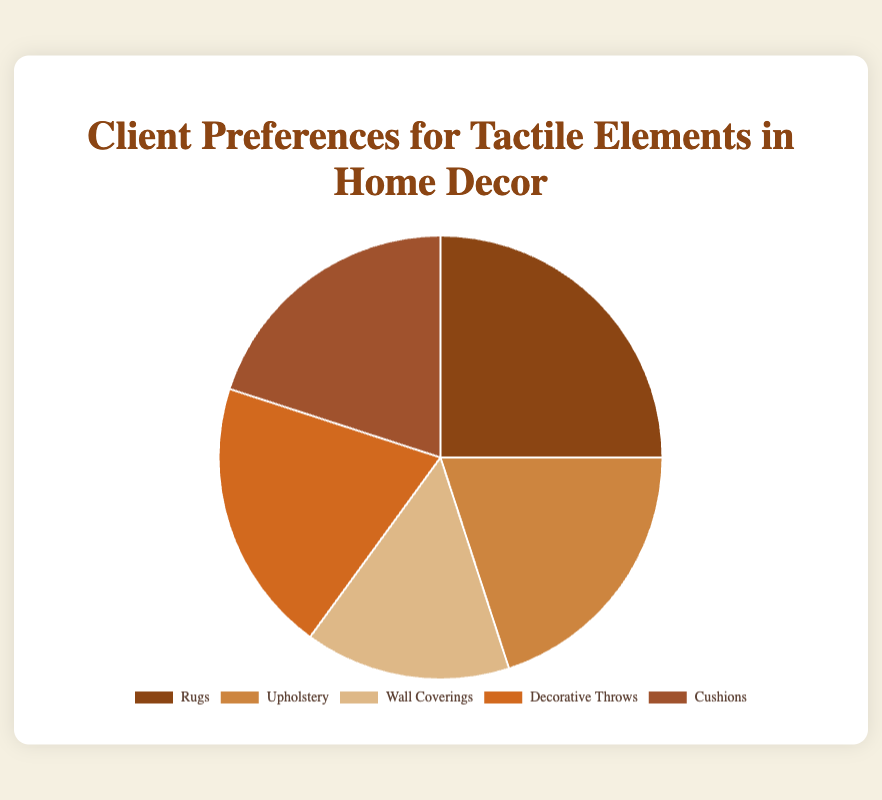What percentage of clients prefer Rugs? The segment labeled "Rugs" in the pie chart represents 25% of the preferences.
Answer: 25% Which categories have equal client preference percentages? The pie chart shows that Upholstery, Decorative Throws, and Cushions each have a preference percentage of 20%.
Answer: Upholstery, Decorative Throws, Cushions What is the combined percentage preference for Upholstery and Cushions? Add the percentages for Upholstery (20%) and Cushions (20%): 20% + 20% = 40%.
Answer: 40% If you were to segment the preferences into "Floor-related" (Rugs) and "Other", what would be the preference percentages for these segments? Rugs represent 25%. The combined percentage for Upholstery, Wall Coverings, Decorative Throws, and Cushions is: 20% + 15% + 20% + 20% = 75%.
Answer: 25% for Rugs, 75% for Others Which category has the least client preference, and what is its percentage? The segment labeled "Wall Coverings" has the smallest slice in the pie chart, representing 15%.
Answer: Wall Coverings, 15% What percentage of clients prefer elements other than Rugs? Subtract Rugs' percentage (25%) from the total (100%): 100% - 25% = 75%.
Answer: 75% How does the preference for Decorative Throws compare to that for Wall Coverings? Decorative Throws have a preference percentage of 20%, whereas Wall Coverings have 15%. Hence, Decorative Throws have a higher preference by 5%.
Answer: Decorative Throws are preferred 5% more than Wall Coverings What is the average preference percentage for all categories? Sum all percentages: 25% + 20% + 15% + 20% + 20% = 100%. There are 5 categories, so divide the total by 5: 100% / 5 = 20%.
Answer: 20% Identify the category represented by the darkest color in the pie chart, and state its preference percentage. The darkest color represents the category "Rugs," which has a preference percentage of 25%.
Answer: Rugs, 25% Calculate the difference in percentage preference between the most and least preferred tactile elements. The most preferred is Rugs (25%), and the least preferred is Wall Coverings (15%). The difference is 25% - 15% = 10%.
Answer: 10% 